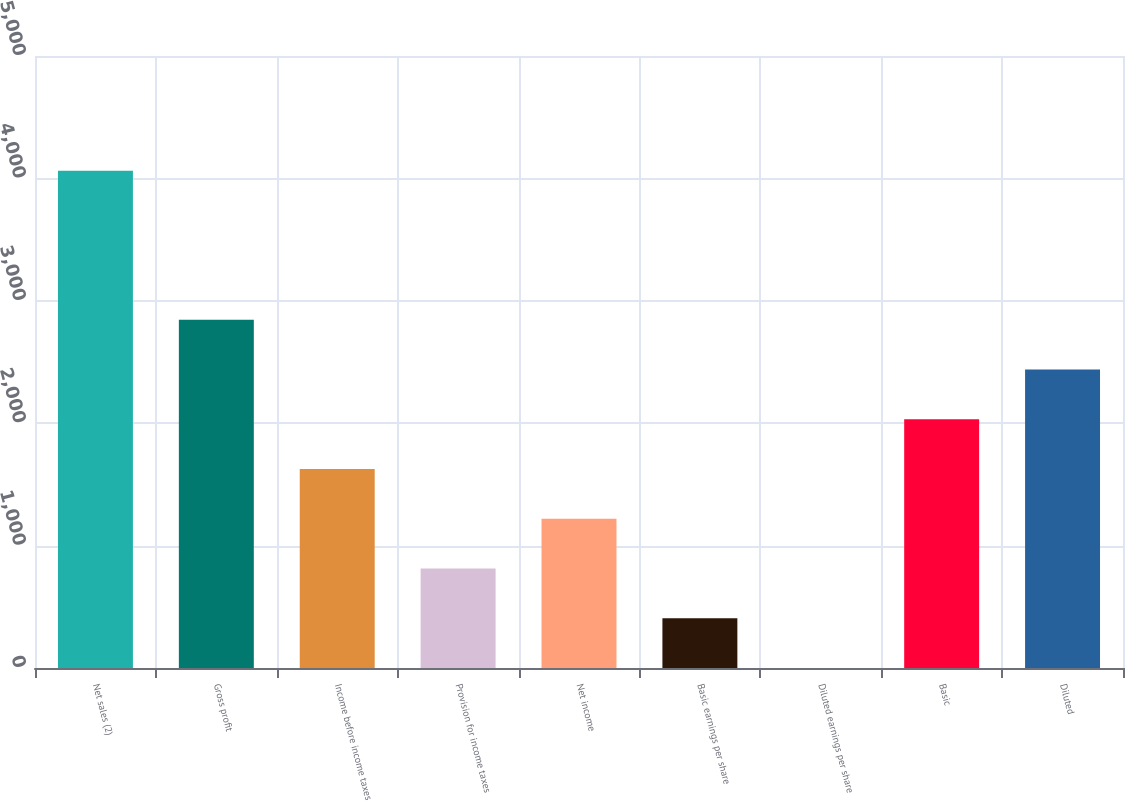<chart> <loc_0><loc_0><loc_500><loc_500><bar_chart><fcel>Net sales (2)<fcel>Gross profit<fcel>Income before income taxes<fcel>Provision for income taxes<fcel>Net income<fcel>Basic earnings per share<fcel>Diluted earnings per share<fcel>Basic<fcel>Diluted<nl><fcel>4063<fcel>2844.19<fcel>1625.41<fcel>812.89<fcel>1219.15<fcel>406.63<fcel>0.37<fcel>2031.67<fcel>2437.93<nl></chart> 